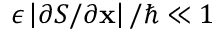Convert formula to latex. <formula><loc_0><loc_0><loc_500><loc_500>\epsilon \left | \partial S / \partial x \right | / \hbar { \ll } 1</formula> 